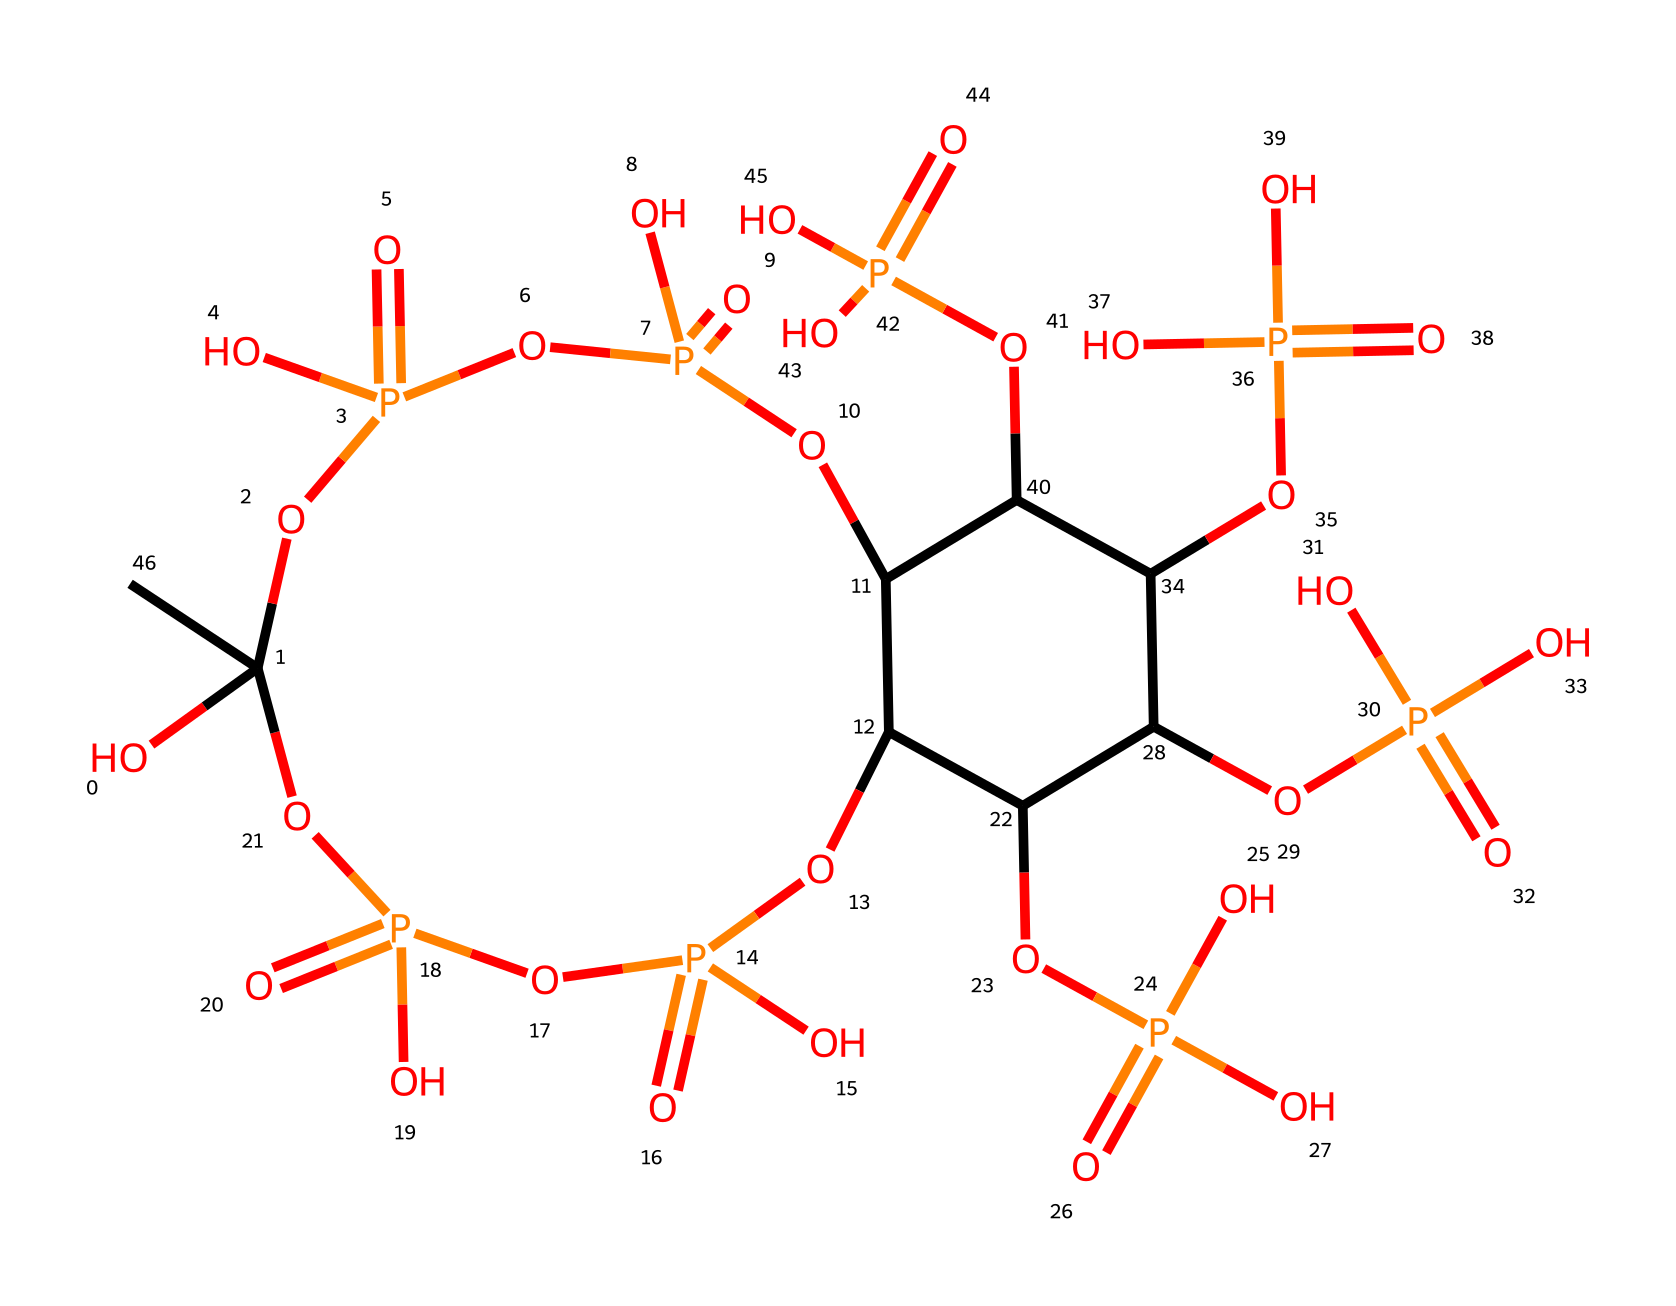What is the molecular formula of phytic acid? In the structure represented by the SMILES provided, we can count the atoms of carbon (C), hydrogen (H), nitrogen (N), oxygen (O), and phosphorus (P) by analyzing the connectivity of the structure based on the SMILES notation. The molecular formula is derived by tallying these atoms. For phytic acid, the molecular formula is C6H18O24P6.
Answer: C6H18O24P6 How many phosphorus atoms are present in phytic acid? By examining the SMILES representation, we can identify the instances of phosphorus (P). In this case, we can count six phosphorus atoms in the structure of phytic acid, each denoted by the letter "P".
Answer: 6 What type of bonding is prevalent in phytic acid? The presence of multiple phosphate groups indicates that phytic acid is characterized by covalent bonding. Specifically, the oxygens are covalently bonded to phosphorus in the phosphate groups, typical of this kind of compound.
Answer: covalent How many ring structures are involved in phytic acid? Analyzing the structure indicates that it contains one main cyclic structure along with a branching configuration of phosphate and carbon units. The cyclic nature can be inferred from the connections and closures in the SMILES notation.
Answer: 1 What functional group is primarily responsible for the water solubility of phytic acid? The presence of multiple phosphate groups (P=O and P-OH) contributes to the hydrophilicity of the molecule due to their ability to form hydrogen bonds with water molecules, making the compound water-soluble.
Answer: phosphate group What property does the presence of multiple phosphate groups impart on phytic acid? The abundance of phosphate groups in phytic acid contributes to its ability to chelate metal ions, which is a common property of phosphorus compounds, aiding in mineral absorption in biological systems.
Answer: chelation 